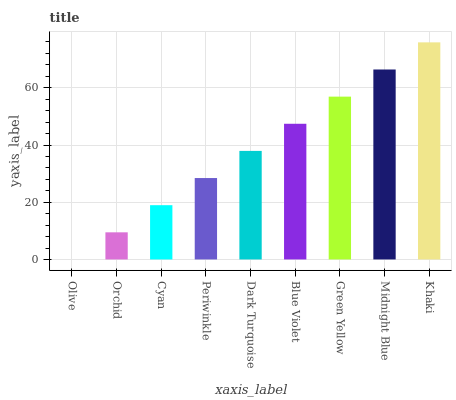Is Olive the minimum?
Answer yes or no. Yes. Is Khaki the maximum?
Answer yes or no. Yes. Is Orchid the minimum?
Answer yes or no. No. Is Orchid the maximum?
Answer yes or no. No. Is Orchid greater than Olive?
Answer yes or no. Yes. Is Olive less than Orchid?
Answer yes or no. Yes. Is Olive greater than Orchid?
Answer yes or no. No. Is Orchid less than Olive?
Answer yes or no. No. Is Dark Turquoise the high median?
Answer yes or no. Yes. Is Dark Turquoise the low median?
Answer yes or no. Yes. Is Cyan the high median?
Answer yes or no. No. Is Cyan the low median?
Answer yes or no. No. 